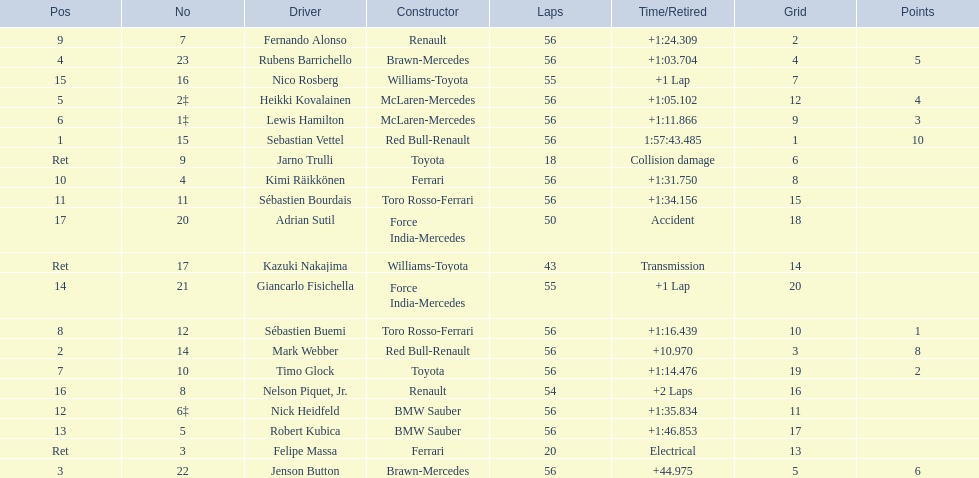What is the name of a driver that ferrari was not a constructor for? Sebastian Vettel. 